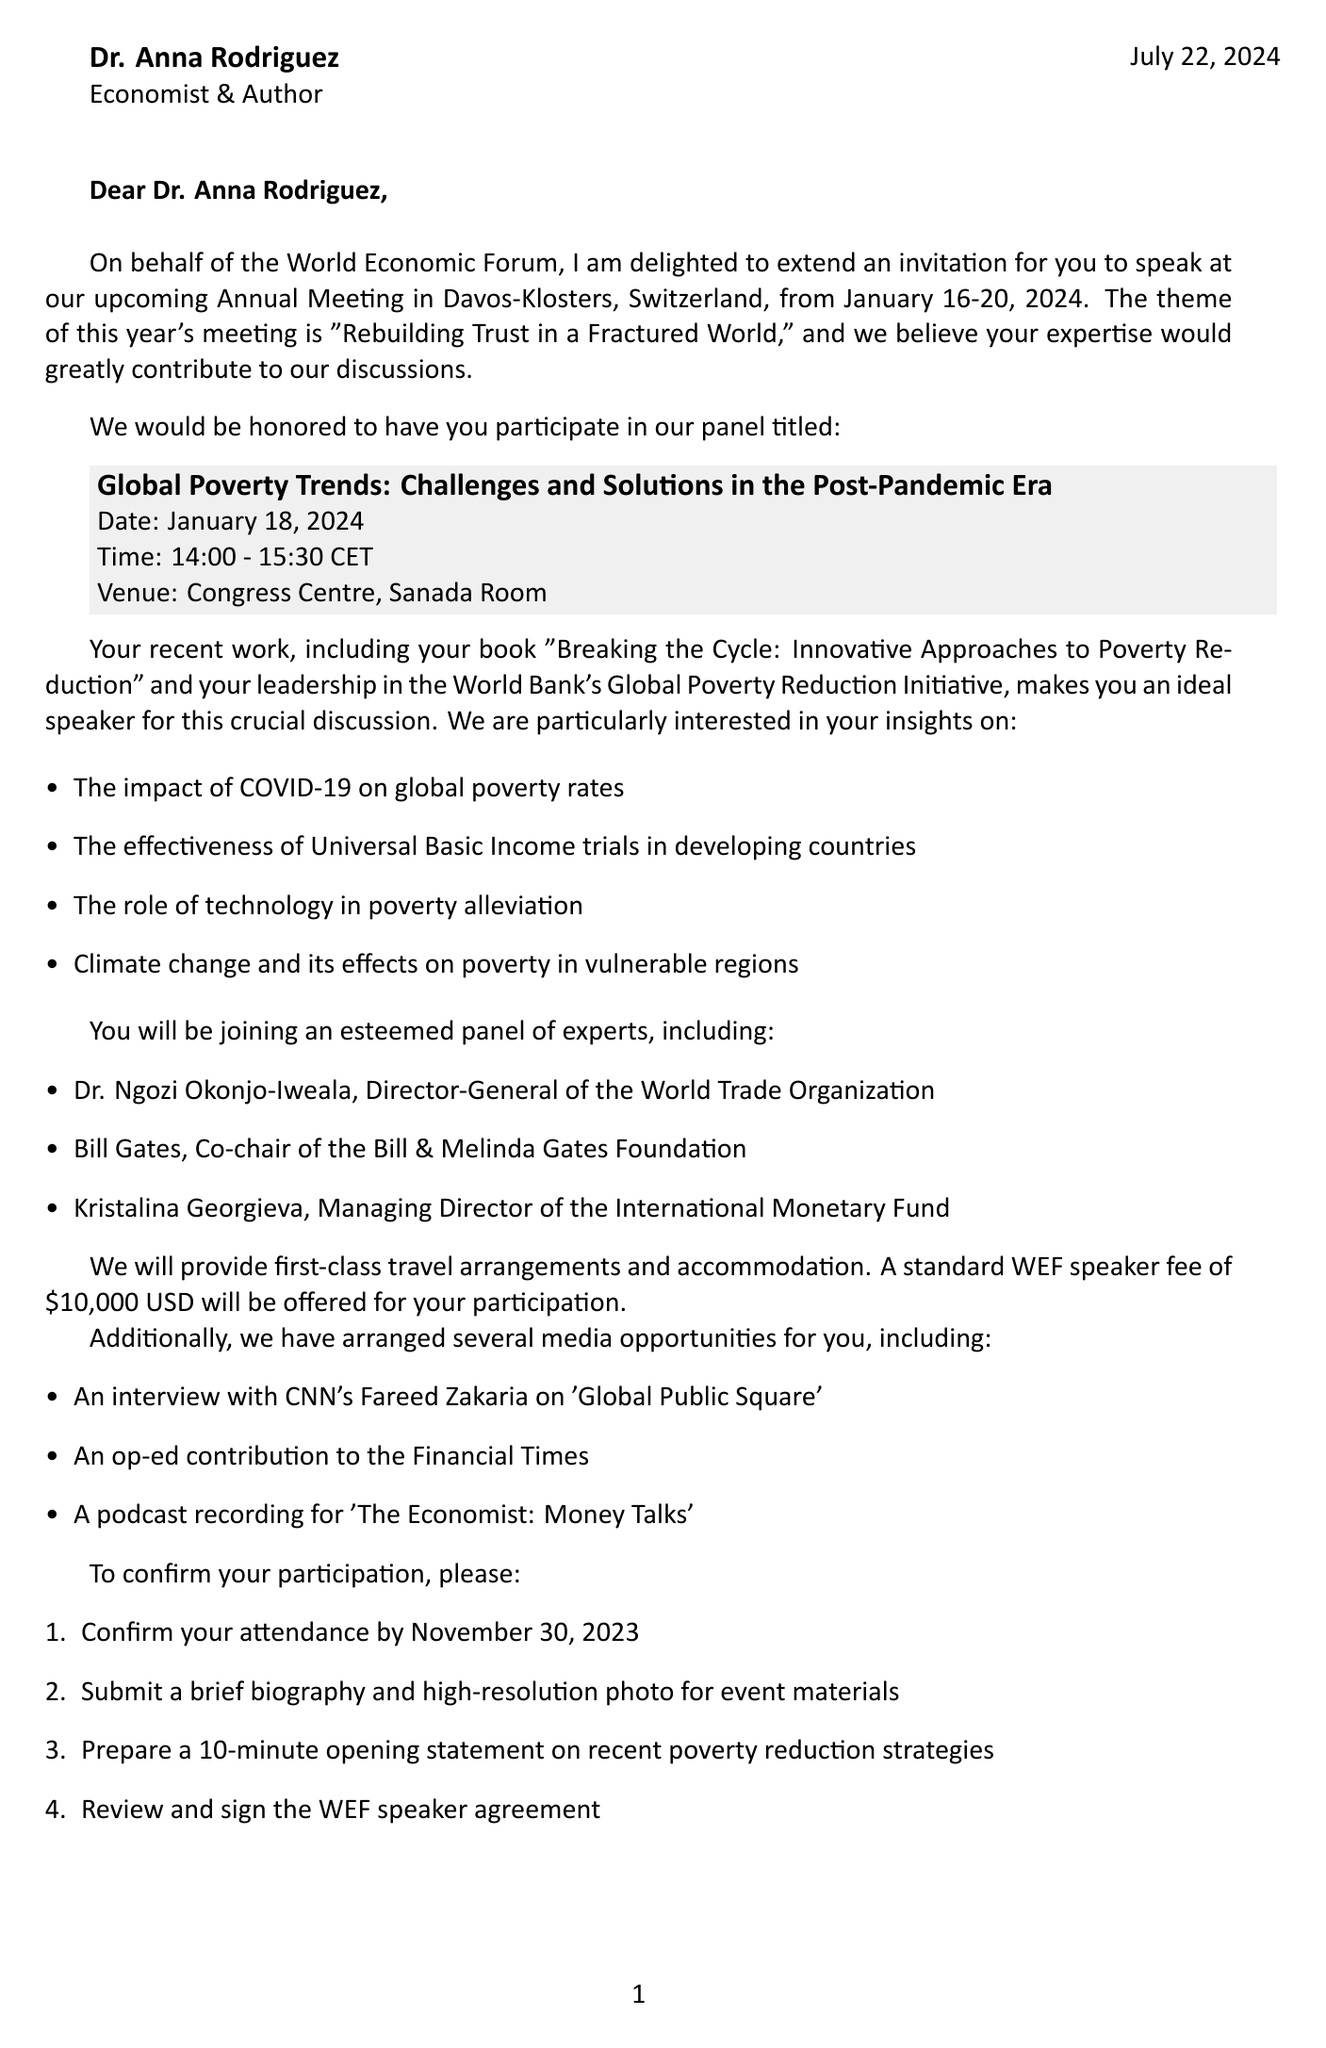What is the name of the event? The name of the event is explicitly mentioned in the document as the "World Economic Forum Annual Meeting."
Answer: World Economic Forum Annual Meeting What is the date of the speaking engagement? The date for the speaking engagement is specified in the document.
Answer: January 18, 2024 Who is inviting Dr. Anna Rodriguez to speak? The inviter's name and title are provided in the document.
Answer: Børge Brende What is the honorarium offered to Dr. Anna Rodriguez? The document states the standard fee offered for participation.
Answer: $10,000 USD What are the key topics she is expected to discuss? The document outlines several topics for discussion, detailing the issues to be addressed on the panel.
Answer: Impact of COVID-19 on global poverty rates, Effectiveness of Universal Basic Income trials in developing countries, Role of technology in poverty alleviation, Climate change and its effects on poverty in vulnerable regions Who are the fellow panelists? The document provides names and titles of those participating on the panel with Dr. Anna Rodriguez.
Answer: Dr. Ngozi Okonjo-Iweala, Bill Gates, Kristalina Georgieva What is the theme of this year's World Economic Forum meeting? The theme for the meeting is stated in the document as part of the invitation.
Answer: Rebuilding Trust in a Fractured World What is the venue for the panel discussion? The specific location of the panel discussion is mentioned in the document.
Answer: Congress Centre, Sanada Room When is the deadline to confirm attendance? The document specifies a date by which to confirm participation.
Answer: November 30, 2023 